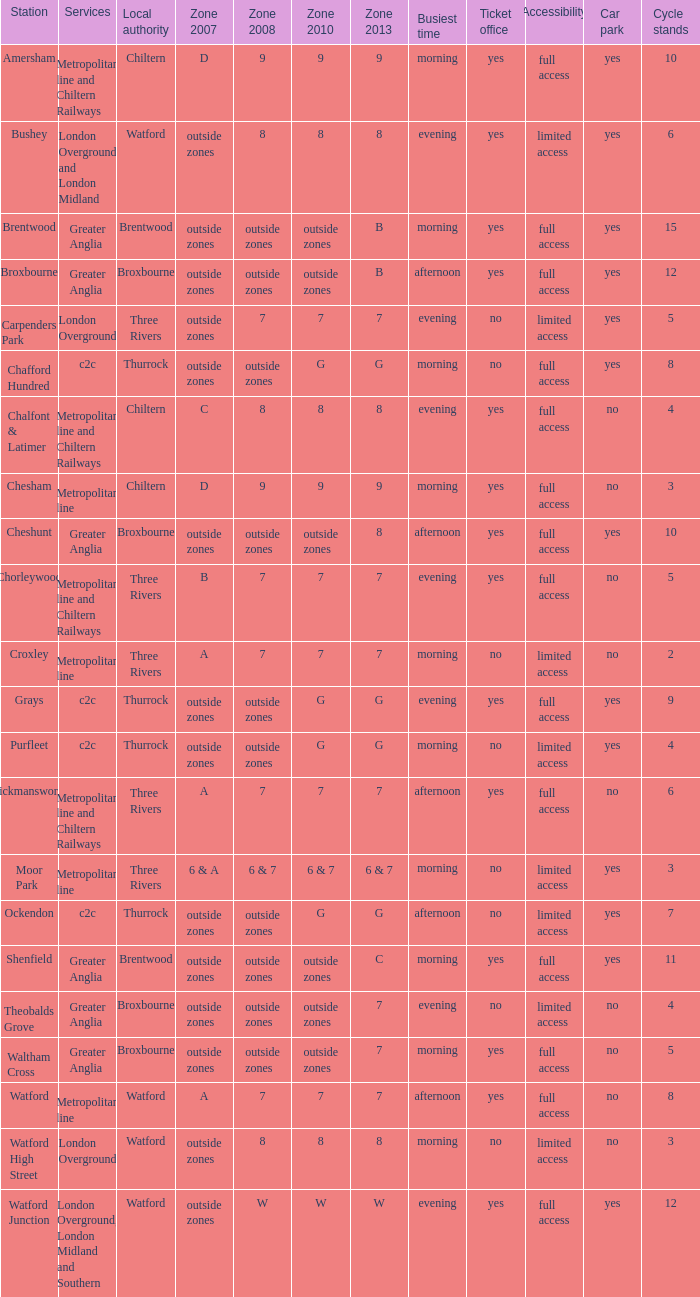Which Zone 2008 has Services of greater anglia, and a Station of cheshunt? Outside zones. 